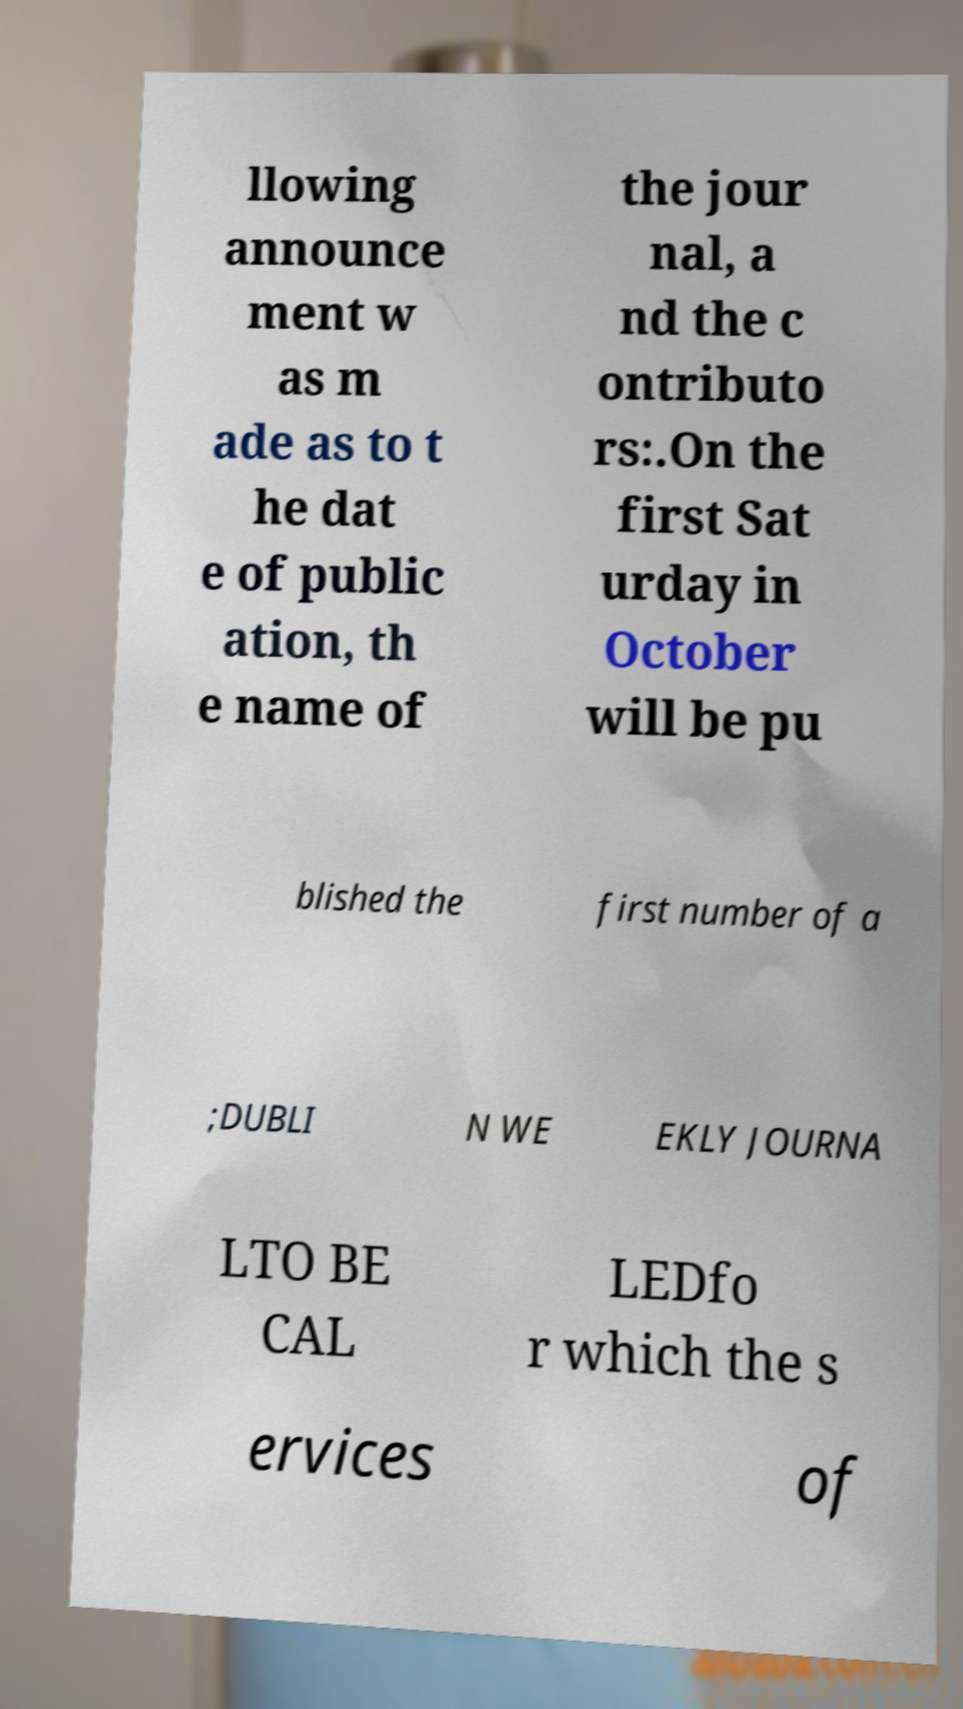What messages or text are displayed in this image? I need them in a readable, typed format. llowing announce ment w as m ade as to t he dat e of public ation, th e name of the jour nal, a nd the c ontributo rs:.On the first Sat urday in October will be pu blished the first number of a ;DUBLI N WE EKLY JOURNA LTO BE CAL LEDfo r which the s ervices of 